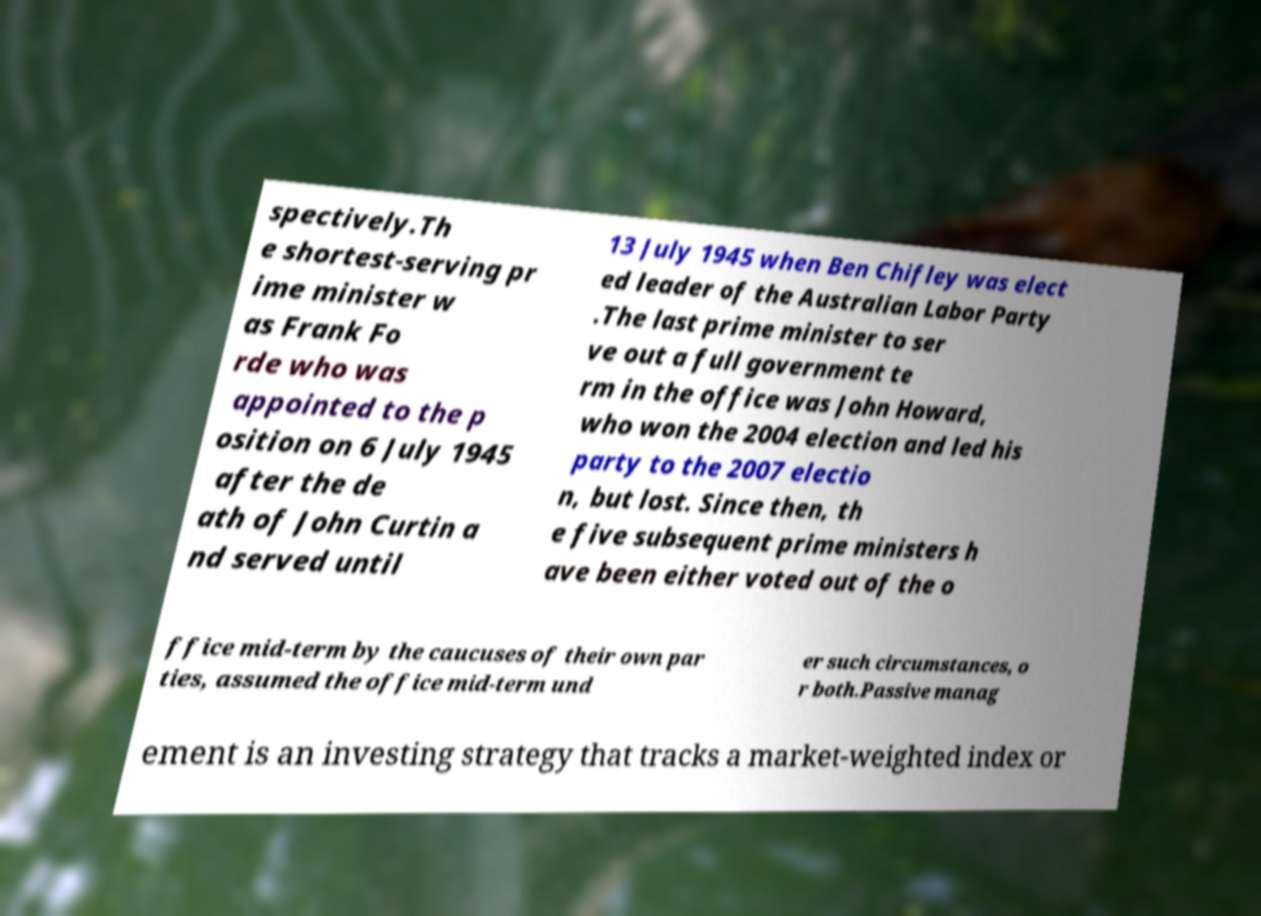Could you assist in decoding the text presented in this image and type it out clearly? spectively.Th e shortest-serving pr ime minister w as Frank Fo rde who was appointed to the p osition on 6 July 1945 after the de ath of John Curtin a nd served until 13 July 1945 when Ben Chifley was elect ed leader of the Australian Labor Party .The last prime minister to ser ve out a full government te rm in the office was John Howard, who won the 2004 election and led his party to the 2007 electio n, but lost. Since then, th e five subsequent prime ministers h ave been either voted out of the o ffice mid-term by the caucuses of their own par ties, assumed the office mid-term und er such circumstances, o r both.Passive manag ement is an investing strategy that tracks a market-weighted index or 